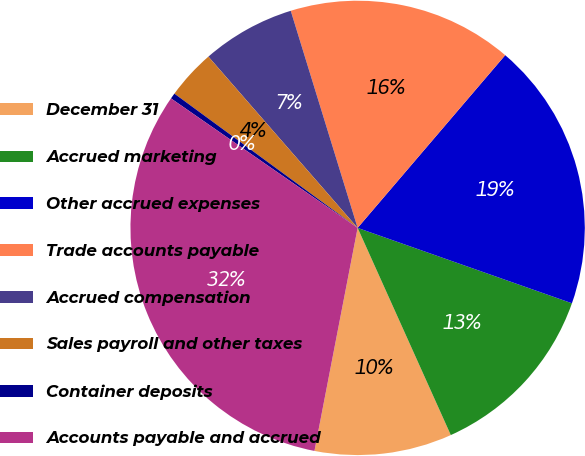<chart> <loc_0><loc_0><loc_500><loc_500><pie_chart><fcel>December 31<fcel>Accrued marketing<fcel>Other accrued expenses<fcel>Trade accounts payable<fcel>Accrued compensation<fcel>Sales payroll and other taxes<fcel>Container deposits<fcel>Accounts payable and accrued<nl><fcel>9.77%<fcel>12.89%<fcel>19.13%<fcel>16.01%<fcel>6.65%<fcel>3.53%<fcel>0.41%<fcel>31.61%<nl></chart> 